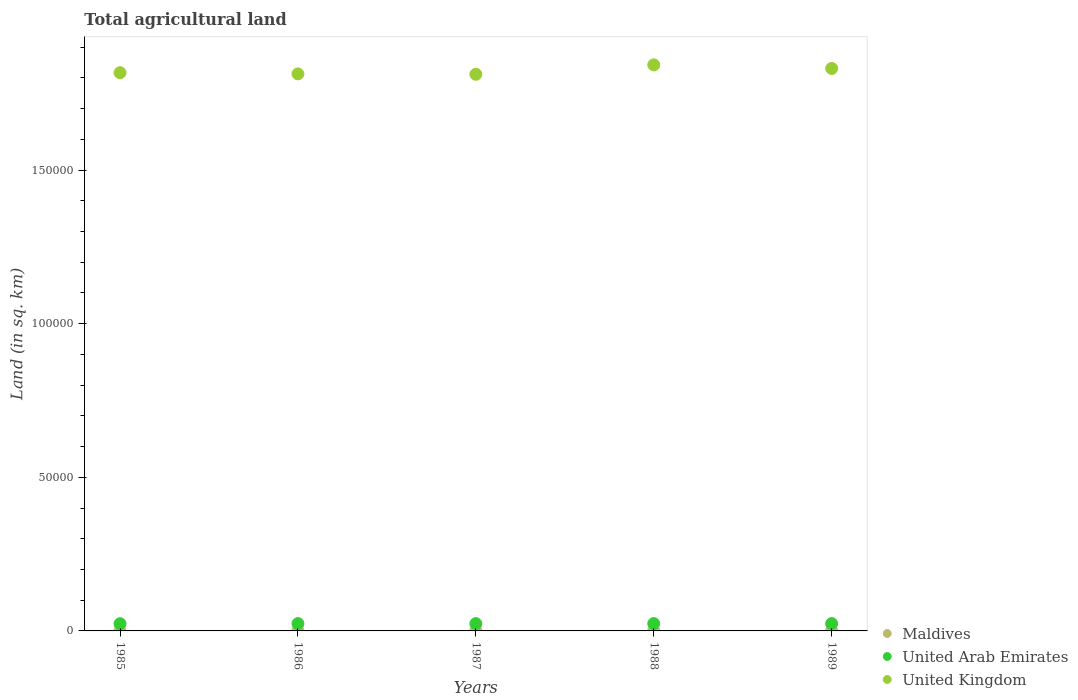How many different coloured dotlines are there?
Provide a short and direct response. 3. What is the total agricultural land in United Kingdom in 1985?
Provide a short and direct response. 1.82e+05. Across all years, what is the maximum total agricultural land in United Kingdom?
Give a very brief answer. 1.84e+05. Across all years, what is the minimum total agricultural land in United Arab Emirates?
Give a very brief answer. 2350. What is the total total agricultural land in Maldives in the graph?
Provide a short and direct response. 400. What is the difference between the total agricultural land in United Kingdom in 1985 and that in 1987?
Provide a short and direct response. 520. What is the difference between the total agricultural land in Maldives in 1988 and the total agricultural land in United Kingdom in 1987?
Your answer should be compact. -1.81e+05. What is the average total agricultural land in United Kingdom per year?
Your answer should be very brief. 1.82e+05. In the year 1987, what is the difference between the total agricultural land in United Kingdom and total agricultural land in United Arab Emirates?
Give a very brief answer. 1.79e+05. In how many years, is the total agricultural land in United Arab Emirates greater than 150000 sq.km?
Provide a short and direct response. 0. What is the ratio of the total agricultural land in United Kingdom in 1985 to that in 1986?
Your answer should be compact. 1. Is the total agricultural land in Maldives in 1985 less than that in 1986?
Your answer should be very brief. No. What is the difference between the highest and the lowest total agricultural land in United Kingdom?
Provide a succinct answer. 3070. In how many years, is the total agricultural land in United Kingdom greater than the average total agricultural land in United Kingdom taken over all years?
Your answer should be very brief. 2. Is the total agricultural land in United Kingdom strictly less than the total agricultural land in United Arab Emirates over the years?
Offer a terse response. No. What is the difference between two consecutive major ticks on the Y-axis?
Your answer should be very brief. 5.00e+04. Does the graph contain any zero values?
Your response must be concise. No. How many legend labels are there?
Offer a terse response. 3. What is the title of the graph?
Your answer should be compact. Total agricultural land. What is the label or title of the Y-axis?
Provide a short and direct response. Land (in sq. km). What is the Land (in sq. km) of Maldives in 1985?
Your answer should be compact. 80. What is the Land (in sq. km) of United Arab Emirates in 1985?
Offer a terse response. 2350. What is the Land (in sq. km) in United Kingdom in 1985?
Your response must be concise. 1.82e+05. What is the Land (in sq. km) of Maldives in 1986?
Offer a terse response. 80. What is the Land (in sq. km) in United Arab Emirates in 1986?
Offer a terse response. 2380. What is the Land (in sq. km) of United Kingdom in 1986?
Provide a succinct answer. 1.81e+05. What is the Land (in sq. km) in United Arab Emirates in 1987?
Your response must be concise. 2380. What is the Land (in sq. km) of United Kingdom in 1987?
Make the answer very short. 1.81e+05. What is the Land (in sq. km) in United Arab Emirates in 1988?
Offer a very short reply. 2390. What is the Land (in sq. km) of United Kingdom in 1988?
Give a very brief answer. 1.84e+05. What is the Land (in sq. km) of United Arab Emirates in 1989?
Offer a very short reply. 2390. What is the Land (in sq. km) in United Kingdom in 1989?
Give a very brief answer. 1.83e+05. Across all years, what is the maximum Land (in sq. km) in United Arab Emirates?
Offer a very short reply. 2390. Across all years, what is the maximum Land (in sq. km) in United Kingdom?
Offer a very short reply. 1.84e+05. Across all years, what is the minimum Land (in sq. km) of United Arab Emirates?
Your answer should be very brief. 2350. Across all years, what is the minimum Land (in sq. km) in United Kingdom?
Offer a terse response. 1.81e+05. What is the total Land (in sq. km) of United Arab Emirates in the graph?
Your answer should be compact. 1.19e+04. What is the total Land (in sq. km) of United Kingdom in the graph?
Offer a very short reply. 9.11e+05. What is the difference between the Land (in sq. km) in United Arab Emirates in 1985 and that in 1986?
Your answer should be very brief. -30. What is the difference between the Land (in sq. km) in United Kingdom in 1985 and that in 1986?
Offer a terse response. 380. What is the difference between the Land (in sq. km) of United Arab Emirates in 1985 and that in 1987?
Your answer should be compact. -30. What is the difference between the Land (in sq. km) of United Kingdom in 1985 and that in 1987?
Ensure brevity in your answer.  520. What is the difference between the Land (in sq. km) of United Kingdom in 1985 and that in 1988?
Keep it short and to the point. -2550. What is the difference between the Land (in sq. km) in Maldives in 1985 and that in 1989?
Provide a succinct answer. 0. What is the difference between the Land (in sq. km) of United Kingdom in 1985 and that in 1989?
Offer a very short reply. -1380. What is the difference between the Land (in sq. km) in United Kingdom in 1986 and that in 1987?
Offer a very short reply. 140. What is the difference between the Land (in sq. km) of Maldives in 1986 and that in 1988?
Your response must be concise. 0. What is the difference between the Land (in sq. km) of United Arab Emirates in 1986 and that in 1988?
Ensure brevity in your answer.  -10. What is the difference between the Land (in sq. km) of United Kingdom in 1986 and that in 1988?
Provide a succinct answer. -2930. What is the difference between the Land (in sq. km) of Maldives in 1986 and that in 1989?
Your response must be concise. 0. What is the difference between the Land (in sq. km) of United Arab Emirates in 1986 and that in 1989?
Provide a short and direct response. -10. What is the difference between the Land (in sq. km) in United Kingdom in 1986 and that in 1989?
Provide a succinct answer. -1760. What is the difference between the Land (in sq. km) in Maldives in 1987 and that in 1988?
Your response must be concise. 0. What is the difference between the Land (in sq. km) of United Kingdom in 1987 and that in 1988?
Give a very brief answer. -3070. What is the difference between the Land (in sq. km) in United Arab Emirates in 1987 and that in 1989?
Make the answer very short. -10. What is the difference between the Land (in sq. km) of United Kingdom in 1987 and that in 1989?
Your response must be concise. -1900. What is the difference between the Land (in sq. km) of Maldives in 1988 and that in 1989?
Keep it short and to the point. 0. What is the difference between the Land (in sq. km) in United Arab Emirates in 1988 and that in 1989?
Provide a short and direct response. 0. What is the difference between the Land (in sq. km) of United Kingdom in 1988 and that in 1989?
Your answer should be very brief. 1170. What is the difference between the Land (in sq. km) in Maldives in 1985 and the Land (in sq. km) in United Arab Emirates in 1986?
Provide a short and direct response. -2300. What is the difference between the Land (in sq. km) in Maldives in 1985 and the Land (in sq. km) in United Kingdom in 1986?
Give a very brief answer. -1.81e+05. What is the difference between the Land (in sq. km) of United Arab Emirates in 1985 and the Land (in sq. km) of United Kingdom in 1986?
Provide a succinct answer. -1.79e+05. What is the difference between the Land (in sq. km) in Maldives in 1985 and the Land (in sq. km) in United Arab Emirates in 1987?
Your answer should be compact. -2300. What is the difference between the Land (in sq. km) of Maldives in 1985 and the Land (in sq. km) of United Kingdom in 1987?
Give a very brief answer. -1.81e+05. What is the difference between the Land (in sq. km) of United Arab Emirates in 1985 and the Land (in sq. km) of United Kingdom in 1987?
Your answer should be compact. -1.79e+05. What is the difference between the Land (in sq. km) in Maldives in 1985 and the Land (in sq. km) in United Arab Emirates in 1988?
Provide a succinct answer. -2310. What is the difference between the Land (in sq. km) in Maldives in 1985 and the Land (in sq. km) in United Kingdom in 1988?
Offer a terse response. -1.84e+05. What is the difference between the Land (in sq. km) of United Arab Emirates in 1985 and the Land (in sq. km) of United Kingdom in 1988?
Give a very brief answer. -1.82e+05. What is the difference between the Land (in sq. km) of Maldives in 1985 and the Land (in sq. km) of United Arab Emirates in 1989?
Keep it short and to the point. -2310. What is the difference between the Land (in sq. km) in Maldives in 1985 and the Land (in sq. km) in United Kingdom in 1989?
Keep it short and to the point. -1.83e+05. What is the difference between the Land (in sq. km) of United Arab Emirates in 1985 and the Land (in sq. km) of United Kingdom in 1989?
Offer a very short reply. -1.81e+05. What is the difference between the Land (in sq. km) of Maldives in 1986 and the Land (in sq. km) of United Arab Emirates in 1987?
Make the answer very short. -2300. What is the difference between the Land (in sq. km) in Maldives in 1986 and the Land (in sq. km) in United Kingdom in 1987?
Provide a succinct answer. -1.81e+05. What is the difference between the Land (in sq. km) in United Arab Emirates in 1986 and the Land (in sq. km) in United Kingdom in 1987?
Give a very brief answer. -1.79e+05. What is the difference between the Land (in sq. km) in Maldives in 1986 and the Land (in sq. km) in United Arab Emirates in 1988?
Your answer should be very brief. -2310. What is the difference between the Land (in sq. km) in Maldives in 1986 and the Land (in sq. km) in United Kingdom in 1988?
Offer a terse response. -1.84e+05. What is the difference between the Land (in sq. km) of United Arab Emirates in 1986 and the Land (in sq. km) of United Kingdom in 1988?
Your answer should be very brief. -1.82e+05. What is the difference between the Land (in sq. km) in Maldives in 1986 and the Land (in sq. km) in United Arab Emirates in 1989?
Your response must be concise. -2310. What is the difference between the Land (in sq. km) of Maldives in 1986 and the Land (in sq. km) of United Kingdom in 1989?
Keep it short and to the point. -1.83e+05. What is the difference between the Land (in sq. km) in United Arab Emirates in 1986 and the Land (in sq. km) in United Kingdom in 1989?
Give a very brief answer. -1.81e+05. What is the difference between the Land (in sq. km) in Maldives in 1987 and the Land (in sq. km) in United Arab Emirates in 1988?
Offer a terse response. -2310. What is the difference between the Land (in sq. km) in Maldives in 1987 and the Land (in sq. km) in United Kingdom in 1988?
Provide a succinct answer. -1.84e+05. What is the difference between the Land (in sq. km) of United Arab Emirates in 1987 and the Land (in sq. km) of United Kingdom in 1988?
Provide a short and direct response. -1.82e+05. What is the difference between the Land (in sq. km) in Maldives in 1987 and the Land (in sq. km) in United Arab Emirates in 1989?
Make the answer very short. -2310. What is the difference between the Land (in sq. km) of Maldives in 1987 and the Land (in sq. km) of United Kingdom in 1989?
Your response must be concise. -1.83e+05. What is the difference between the Land (in sq. km) in United Arab Emirates in 1987 and the Land (in sq. km) in United Kingdom in 1989?
Your answer should be very brief. -1.81e+05. What is the difference between the Land (in sq. km) of Maldives in 1988 and the Land (in sq. km) of United Arab Emirates in 1989?
Ensure brevity in your answer.  -2310. What is the difference between the Land (in sq. km) in Maldives in 1988 and the Land (in sq. km) in United Kingdom in 1989?
Your answer should be compact. -1.83e+05. What is the difference between the Land (in sq. km) of United Arab Emirates in 1988 and the Land (in sq. km) of United Kingdom in 1989?
Provide a short and direct response. -1.81e+05. What is the average Land (in sq. km) in Maldives per year?
Keep it short and to the point. 80. What is the average Land (in sq. km) in United Arab Emirates per year?
Give a very brief answer. 2378. What is the average Land (in sq. km) of United Kingdom per year?
Give a very brief answer. 1.82e+05. In the year 1985, what is the difference between the Land (in sq. km) of Maldives and Land (in sq. km) of United Arab Emirates?
Provide a succinct answer. -2270. In the year 1985, what is the difference between the Land (in sq. km) in Maldives and Land (in sq. km) in United Kingdom?
Your answer should be compact. -1.82e+05. In the year 1985, what is the difference between the Land (in sq. km) of United Arab Emirates and Land (in sq. km) of United Kingdom?
Offer a very short reply. -1.79e+05. In the year 1986, what is the difference between the Land (in sq. km) of Maldives and Land (in sq. km) of United Arab Emirates?
Offer a terse response. -2300. In the year 1986, what is the difference between the Land (in sq. km) of Maldives and Land (in sq. km) of United Kingdom?
Your answer should be compact. -1.81e+05. In the year 1986, what is the difference between the Land (in sq. km) of United Arab Emirates and Land (in sq. km) of United Kingdom?
Keep it short and to the point. -1.79e+05. In the year 1987, what is the difference between the Land (in sq. km) in Maldives and Land (in sq. km) in United Arab Emirates?
Provide a succinct answer. -2300. In the year 1987, what is the difference between the Land (in sq. km) in Maldives and Land (in sq. km) in United Kingdom?
Your answer should be compact. -1.81e+05. In the year 1987, what is the difference between the Land (in sq. km) of United Arab Emirates and Land (in sq. km) of United Kingdom?
Offer a very short reply. -1.79e+05. In the year 1988, what is the difference between the Land (in sq. km) in Maldives and Land (in sq. km) in United Arab Emirates?
Make the answer very short. -2310. In the year 1988, what is the difference between the Land (in sq. km) in Maldives and Land (in sq. km) in United Kingdom?
Your answer should be very brief. -1.84e+05. In the year 1988, what is the difference between the Land (in sq. km) of United Arab Emirates and Land (in sq. km) of United Kingdom?
Offer a terse response. -1.82e+05. In the year 1989, what is the difference between the Land (in sq. km) in Maldives and Land (in sq. km) in United Arab Emirates?
Ensure brevity in your answer.  -2310. In the year 1989, what is the difference between the Land (in sq. km) in Maldives and Land (in sq. km) in United Kingdom?
Your response must be concise. -1.83e+05. In the year 1989, what is the difference between the Land (in sq. km) of United Arab Emirates and Land (in sq. km) of United Kingdom?
Keep it short and to the point. -1.81e+05. What is the ratio of the Land (in sq. km) in Maldives in 1985 to that in 1986?
Offer a terse response. 1. What is the ratio of the Land (in sq. km) of United Arab Emirates in 1985 to that in 1986?
Give a very brief answer. 0.99. What is the ratio of the Land (in sq. km) of United Kingdom in 1985 to that in 1986?
Keep it short and to the point. 1. What is the ratio of the Land (in sq. km) in United Arab Emirates in 1985 to that in 1987?
Your response must be concise. 0.99. What is the ratio of the Land (in sq. km) in United Arab Emirates in 1985 to that in 1988?
Keep it short and to the point. 0.98. What is the ratio of the Land (in sq. km) in United Kingdom in 1985 to that in 1988?
Offer a terse response. 0.99. What is the ratio of the Land (in sq. km) of Maldives in 1985 to that in 1989?
Your answer should be compact. 1. What is the ratio of the Land (in sq. km) of United Arab Emirates in 1985 to that in 1989?
Ensure brevity in your answer.  0.98. What is the ratio of the Land (in sq. km) in United Kingdom in 1986 to that in 1987?
Ensure brevity in your answer.  1. What is the ratio of the Land (in sq. km) in Maldives in 1986 to that in 1988?
Offer a terse response. 1. What is the ratio of the Land (in sq. km) of United Arab Emirates in 1986 to that in 1988?
Your answer should be very brief. 1. What is the ratio of the Land (in sq. km) in United Kingdom in 1986 to that in 1988?
Offer a very short reply. 0.98. What is the ratio of the Land (in sq. km) of United Arab Emirates in 1986 to that in 1989?
Offer a terse response. 1. What is the ratio of the Land (in sq. km) of United Kingdom in 1986 to that in 1989?
Provide a succinct answer. 0.99. What is the ratio of the Land (in sq. km) in Maldives in 1987 to that in 1988?
Keep it short and to the point. 1. What is the ratio of the Land (in sq. km) of United Kingdom in 1987 to that in 1988?
Ensure brevity in your answer.  0.98. What is the ratio of the Land (in sq. km) in Maldives in 1987 to that in 1989?
Offer a terse response. 1. What is the ratio of the Land (in sq. km) of United Arab Emirates in 1987 to that in 1989?
Keep it short and to the point. 1. What is the ratio of the Land (in sq. km) in United Kingdom in 1987 to that in 1989?
Ensure brevity in your answer.  0.99. What is the ratio of the Land (in sq. km) in United Kingdom in 1988 to that in 1989?
Your answer should be very brief. 1.01. What is the difference between the highest and the second highest Land (in sq. km) in United Arab Emirates?
Provide a short and direct response. 0. What is the difference between the highest and the second highest Land (in sq. km) of United Kingdom?
Provide a succinct answer. 1170. What is the difference between the highest and the lowest Land (in sq. km) of United Arab Emirates?
Your response must be concise. 40. What is the difference between the highest and the lowest Land (in sq. km) of United Kingdom?
Provide a succinct answer. 3070. 